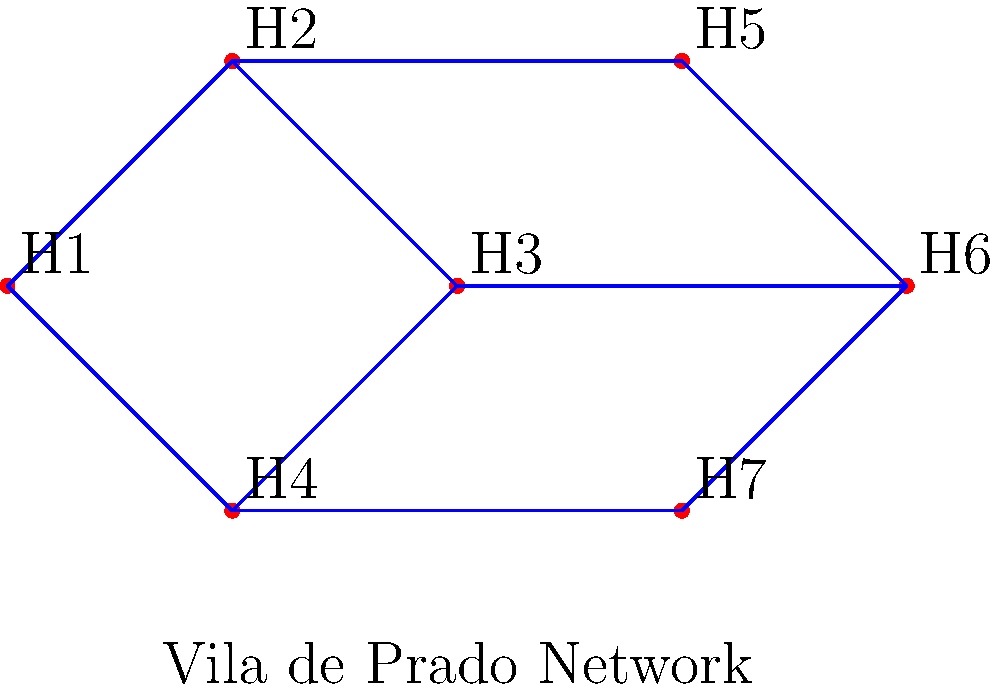In Vila de Prado, a new housing development needs to be connected to the utility network. The diagram shows 7 houses (H1 to H7) and the possible connections between them. What is the minimum number of connections needed to ensure all houses are connected to the utility network while minimizing the total length of connections? To solve this problem, we need to find the minimum spanning tree of the given graph. Here's a step-by-step approach:

1. Identify the vertices: There are 7 houses (H1 to H7) represented as vertices.

2. Count the edges: There are 8 edges in the given graph.

3. Apply Kruskal's algorithm to find the minimum spanning tree:
   a. Sort the edges by length (assume all edges have unit length for simplicity).
   b. Start with an empty set of edges.
   c. Add edges one by one, ensuring no cycles are formed.

4. The minimum spanning tree will connect all vertices (houses) with the minimum number of edges.

5. Count the number of edges in the minimum spanning tree:
   - A tree with 7 vertices always has 6 edges.

Therefore, the minimum number of connections needed to ensure all houses are connected while minimizing the total length is 6.

This solution ensures that all houses in Vila de Prado are connected to the utility network with the least amount of infrastructure, which is both cost-effective and efficient.
Answer: 6 connections 